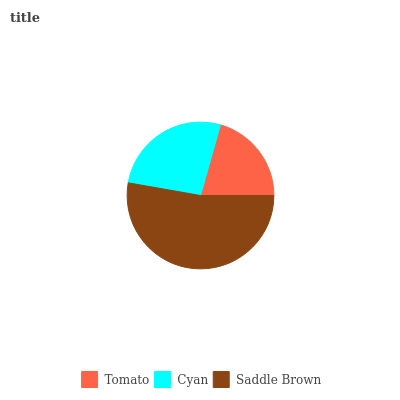Is Tomato the minimum?
Answer yes or no. Yes. Is Saddle Brown the maximum?
Answer yes or no. Yes. Is Cyan the minimum?
Answer yes or no. No. Is Cyan the maximum?
Answer yes or no. No. Is Cyan greater than Tomato?
Answer yes or no. Yes. Is Tomato less than Cyan?
Answer yes or no. Yes. Is Tomato greater than Cyan?
Answer yes or no. No. Is Cyan less than Tomato?
Answer yes or no. No. Is Cyan the high median?
Answer yes or no. Yes. Is Cyan the low median?
Answer yes or no. Yes. Is Tomato the high median?
Answer yes or no. No. Is Tomato the low median?
Answer yes or no. No. 